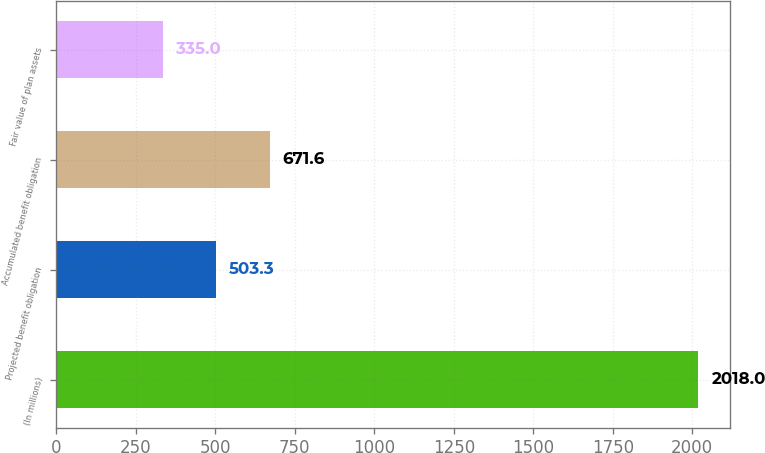Convert chart to OTSL. <chart><loc_0><loc_0><loc_500><loc_500><bar_chart><fcel>(In millions)<fcel>Projected benefit obligation<fcel>Accumulated benefit obligation<fcel>Fair value of plan assets<nl><fcel>2018<fcel>503.3<fcel>671.6<fcel>335<nl></chart> 